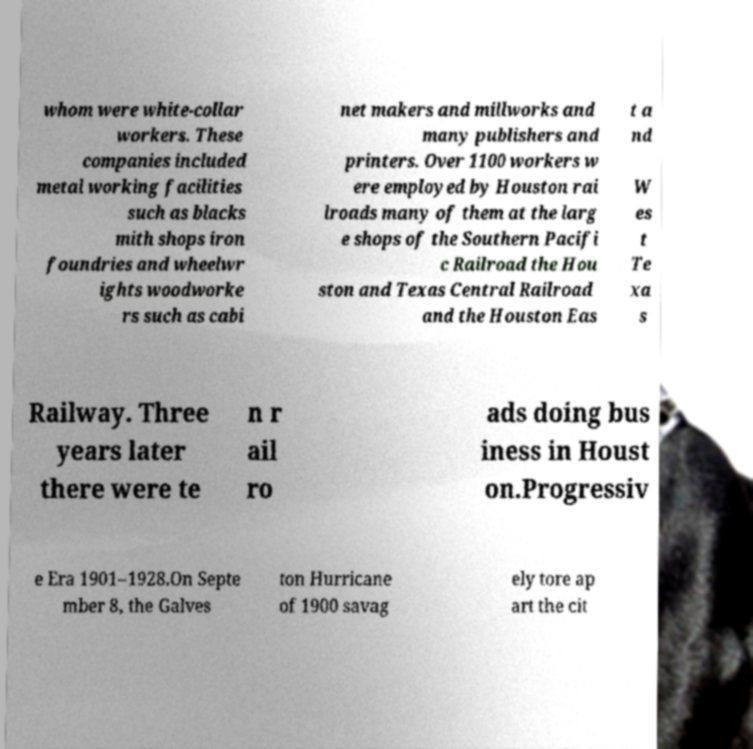Could you assist in decoding the text presented in this image and type it out clearly? whom were white-collar workers. These companies included metal working facilities such as blacks mith shops iron foundries and wheelwr ights woodworke rs such as cabi net makers and millworks and many publishers and printers. Over 1100 workers w ere employed by Houston rai lroads many of them at the larg e shops of the Southern Pacifi c Railroad the Hou ston and Texas Central Railroad and the Houston Eas t a nd W es t Te xa s Railway. Three years later there were te n r ail ro ads doing bus iness in Houst on.Progressiv e Era 1901–1928.On Septe mber 8, the Galves ton Hurricane of 1900 savag ely tore ap art the cit 